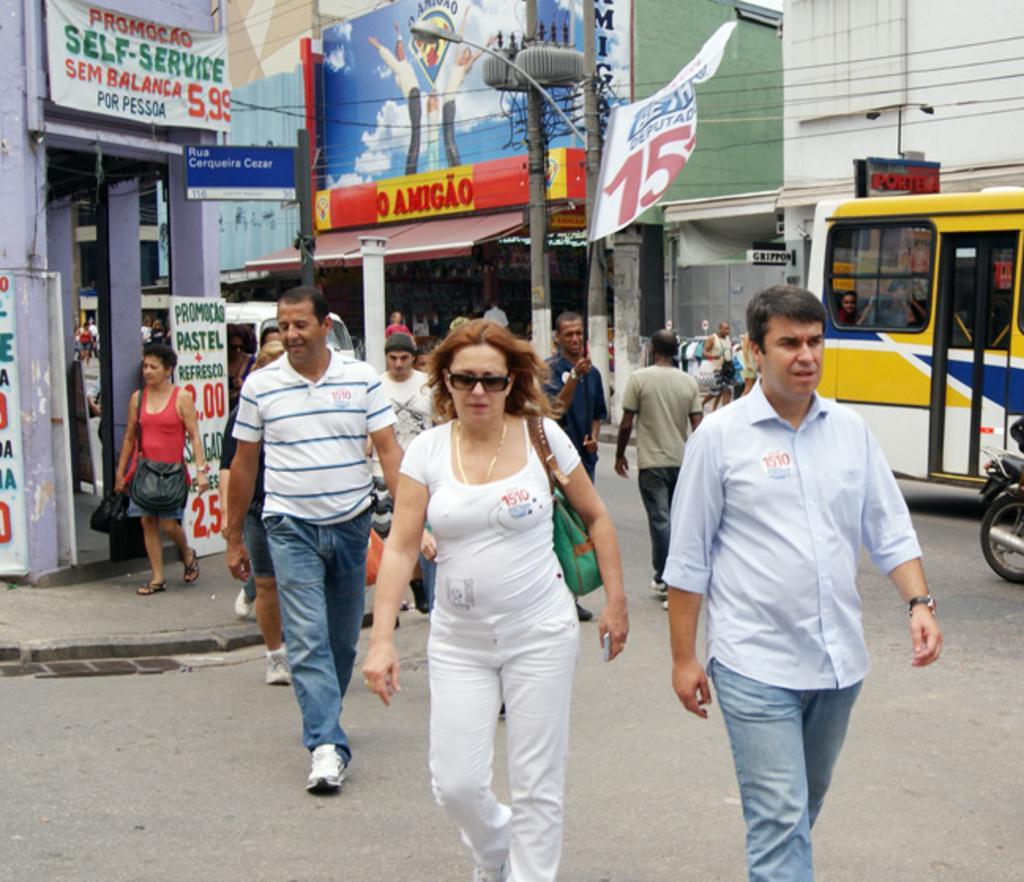In one or two sentences, can you explain what this image depicts? This image is taken outdoors. At the bottom of the image there is a road. In the background there are a few buildings with walls, pillars, doors and roofs. There are many boards with text on them. There are a few poles. Many people are walking on the road and a few vehicles are moving on the road. 